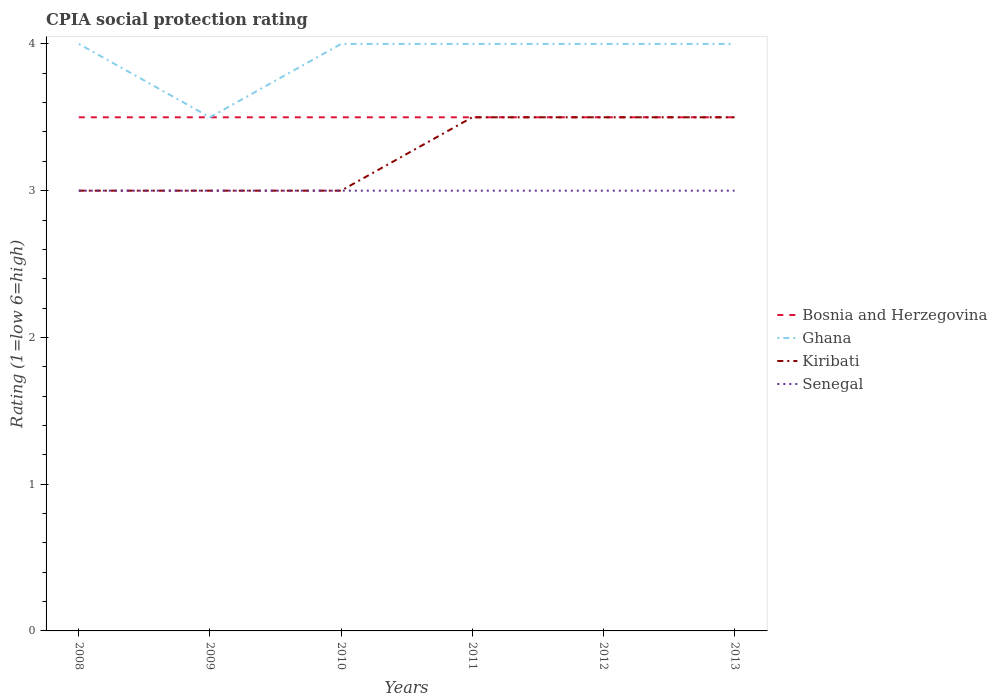Does the line corresponding to Bosnia and Herzegovina intersect with the line corresponding to Kiribati?
Provide a short and direct response. Yes. Across all years, what is the maximum CPIA rating in Senegal?
Provide a succinct answer. 3. In which year was the CPIA rating in Kiribati maximum?
Offer a very short reply. 2008. Is the CPIA rating in Senegal strictly greater than the CPIA rating in Bosnia and Herzegovina over the years?
Provide a succinct answer. Yes. How many years are there in the graph?
Your answer should be very brief. 6. What is the difference between two consecutive major ticks on the Y-axis?
Your answer should be very brief. 1. Does the graph contain grids?
Provide a succinct answer. No. How many legend labels are there?
Provide a short and direct response. 4. What is the title of the graph?
Provide a short and direct response. CPIA social protection rating. What is the label or title of the X-axis?
Provide a short and direct response. Years. What is the label or title of the Y-axis?
Your answer should be compact. Rating (1=low 6=high). What is the Rating (1=low 6=high) of Ghana in 2008?
Offer a very short reply. 4. What is the Rating (1=low 6=high) in Kiribati in 2008?
Your response must be concise. 3. What is the Rating (1=low 6=high) of Senegal in 2008?
Your answer should be compact. 3. What is the Rating (1=low 6=high) of Bosnia and Herzegovina in 2009?
Make the answer very short. 3.5. What is the Rating (1=low 6=high) of Senegal in 2009?
Your response must be concise. 3. What is the Rating (1=low 6=high) of Bosnia and Herzegovina in 2010?
Offer a very short reply. 3.5. What is the Rating (1=low 6=high) in Senegal in 2010?
Provide a succinct answer. 3. What is the Rating (1=low 6=high) in Ghana in 2011?
Give a very brief answer. 4. What is the Rating (1=low 6=high) in Bosnia and Herzegovina in 2012?
Your answer should be very brief. 3.5. What is the Rating (1=low 6=high) in Ghana in 2012?
Make the answer very short. 4. What is the Rating (1=low 6=high) of Kiribati in 2012?
Keep it short and to the point. 3.5. What is the Rating (1=low 6=high) of Bosnia and Herzegovina in 2013?
Your response must be concise. 3.5. What is the Rating (1=low 6=high) in Ghana in 2013?
Keep it short and to the point. 4. Across all years, what is the maximum Rating (1=low 6=high) of Bosnia and Herzegovina?
Your answer should be compact. 3.5. Across all years, what is the maximum Rating (1=low 6=high) in Kiribati?
Ensure brevity in your answer.  3.5. Across all years, what is the maximum Rating (1=low 6=high) of Senegal?
Offer a terse response. 3. Across all years, what is the minimum Rating (1=low 6=high) in Bosnia and Herzegovina?
Give a very brief answer. 3.5. What is the total Rating (1=low 6=high) in Ghana in the graph?
Your answer should be compact. 23.5. What is the difference between the Rating (1=low 6=high) of Ghana in 2008 and that in 2009?
Keep it short and to the point. 0.5. What is the difference between the Rating (1=low 6=high) in Kiribati in 2008 and that in 2009?
Your answer should be compact. 0. What is the difference between the Rating (1=low 6=high) of Senegal in 2008 and that in 2009?
Provide a succinct answer. 0. What is the difference between the Rating (1=low 6=high) of Bosnia and Herzegovina in 2008 and that in 2010?
Make the answer very short. 0. What is the difference between the Rating (1=low 6=high) of Ghana in 2008 and that in 2010?
Your response must be concise. 0. What is the difference between the Rating (1=low 6=high) in Senegal in 2008 and that in 2010?
Offer a terse response. 0. What is the difference between the Rating (1=low 6=high) in Ghana in 2008 and that in 2012?
Offer a terse response. 0. What is the difference between the Rating (1=low 6=high) of Kiribati in 2008 and that in 2012?
Ensure brevity in your answer.  -0.5. What is the difference between the Rating (1=low 6=high) in Senegal in 2008 and that in 2012?
Give a very brief answer. 0. What is the difference between the Rating (1=low 6=high) in Ghana in 2008 and that in 2013?
Provide a short and direct response. 0. What is the difference between the Rating (1=low 6=high) in Kiribati in 2008 and that in 2013?
Your answer should be compact. -0.5. What is the difference between the Rating (1=low 6=high) of Bosnia and Herzegovina in 2009 and that in 2010?
Ensure brevity in your answer.  0. What is the difference between the Rating (1=low 6=high) in Kiribati in 2009 and that in 2010?
Ensure brevity in your answer.  0. What is the difference between the Rating (1=low 6=high) in Senegal in 2009 and that in 2010?
Give a very brief answer. 0. What is the difference between the Rating (1=low 6=high) in Ghana in 2009 and that in 2011?
Make the answer very short. -0.5. What is the difference between the Rating (1=low 6=high) in Senegal in 2009 and that in 2011?
Provide a short and direct response. 0. What is the difference between the Rating (1=low 6=high) of Bosnia and Herzegovina in 2009 and that in 2012?
Make the answer very short. 0. What is the difference between the Rating (1=low 6=high) in Bosnia and Herzegovina in 2010 and that in 2011?
Offer a very short reply. 0. What is the difference between the Rating (1=low 6=high) of Kiribati in 2010 and that in 2011?
Offer a terse response. -0.5. What is the difference between the Rating (1=low 6=high) in Kiribati in 2010 and that in 2012?
Offer a terse response. -0.5. What is the difference between the Rating (1=low 6=high) of Bosnia and Herzegovina in 2010 and that in 2013?
Make the answer very short. 0. What is the difference between the Rating (1=low 6=high) of Ghana in 2010 and that in 2013?
Your response must be concise. 0. What is the difference between the Rating (1=low 6=high) in Ghana in 2011 and that in 2012?
Make the answer very short. 0. What is the difference between the Rating (1=low 6=high) in Senegal in 2011 and that in 2012?
Provide a succinct answer. 0. What is the difference between the Rating (1=low 6=high) of Ghana in 2011 and that in 2013?
Give a very brief answer. 0. What is the difference between the Rating (1=low 6=high) in Kiribati in 2011 and that in 2013?
Your response must be concise. 0. What is the difference between the Rating (1=low 6=high) in Senegal in 2011 and that in 2013?
Offer a terse response. 0. What is the difference between the Rating (1=low 6=high) in Ghana in 2012 and that in 2013?
Your answer should be compact. 0. What is the difference between the Rating (1=low 6=high) in Senegal in 2012 and that in 2013?
Your response must be concise. 0. What is the difference between the Rating (1=low 6=high) of Bosnia and Herzegovina in 2008 and the Rating (1=low 6=high) of Ghana in 2009?
Make the answer very short. 0. What is the difference between the Rating (1=low 6=high) in Ghana in 2008 and the Rating (1=low 6=high) in Kiribati in 2009?
Your answer should be compact. 1. What is the difference between the Rating (1=low 6=high) in Ghana in 2008 and the Rating (1=low 6=high) in Senegal in 2009?
Provide a short and direct response. 1. What is the difference between the Rating (1=low 6=high) of Bosnia and Herzegovina in 2008 and the Rating (1=low 6=high) of Kiribati in 2010?
Ensure brevity in your answer.  0.5. What is the difference between the Rating (1=low 6=high) in Ghana in 2008 and the Rating (1=low 6=high) in Senegal in 2010?
Ensure brevity in your answer.  1. What is the difference between the Rating (1=low 6=high) of Bosnia and Herzegovina in 2008 and the Rating (1=low 6=high) of Kiribati in 2011?
Keep it short and to the point. 0. What is the difference between the Rating (1=low 6=high) in Ghana in 2008 and the Rating (1=low 6=high) in Kiribati in 2011?
Provide a succinct answer. 0.5. What is the difference between the Rating (1=low 6=high) of Bosnia and Herzegovina in 2008 and the Rating (1=low 6=high) of Ghana in 2012?
Give a very brief answer. -0.5. What is the difference between the Rating (1=low 6=high) in Bosnia and Herzegovina in 2008 and the Rating (1=low 6=high) in Senegal in 2012?
Make the answer very short. 0.5. What is the difference between the Rating (1=low 6=high) of Ghana in 2008 and the Rating (1=low 6=high) of Senegal in 2012?
Keep it short and to the point. 1. What is the difference between the Rating (1=low 6=high) in Kiribati in 2008 and the Rating (1=low 6=high) in Senegal in 2012?
Offer a terse response. 0. What is the difference between the Rating (1=low 6=high) in Bosnia and Herzegovina in 2008 and the Rating (1=low 6=high) in Senegal in 2013?
Provide a short and direct response. 0.5. What is the difference between the Rating (1=low 6=high) of Ghana in 2008 and the Rating (1=low 6=high) of Senegal in 2013?
Keep it short and to the point. 1. What is the difference between the Rating (1=low 6=high) of Kiribati in 2008 and the Rating (1=low 6=high) of Senegal in 2013?
Ensure brevity in your answer.  0. What is the difference between the Rating (1=low 6=high) in Bosnia and Herzegovina in 2009 and the Rating (1=low 6=high) in Senegal in 2010?
Provide a succinct answer. 0.5. What is the difference between the Rating (1=low 6=high) in Ghana in 2009 and the Rating (1=low 6=high) in Senegal in 2010?
Your response must be concise. 0.5. What is the difference between the Rating (1=low 6=high) in Bosnia and Herzegovina in 2009 and the Rating (1=low 6=high) in Ghana in 2011?
Your answer should be compact. -0.5. What is the difference between the Rating (1=low 6=high) in Bosnia and Herzegovina in 2009 and the Rating (1=low 6=high) in Senegal in 2011?
Keep it short and to the point. 0.5. What is the difference between the Rating (1=low 6=high) of Ghana in 2009 and the Rating (1=low 6=high) of Kiribati in 2011?
Offer a very short reply. 0. What is the difference between the Rating (1=low 6=high) of Ghana in 2009 and the Rating (1=low 6=high) of Senegal in 2011?
Keep it short and to the point. 0.5. What is the difference between the Rating (1=low 6=high) of Kiribati in 2009 and the Rating (1=low 6=high) of Senegal in 2011?
Provide a succinct answer. 0. What is the difference between the Rating (1=low 6=high) in Bosnia and Herzegovina in 2009 and the Rating (1=low 6=high) in Ghana in 2012?
Ensure brevity in your answer.  -0.5. What is the difference between the Rating (1=low 6=high) of Bosnia and Herzegovina in 2009 and the Rating (1=low 6=high) of Senegal in 2012?
Keep it short and to the point. 0.5. What is the difference between the Rating (1=low 6=high) in Ghana in 2009 and the Rating (1=low 6=high) in Senegal in 2012?
Provide a succinct answer. 0.5. What is the difference between the Rating (1=low 6=high) of Kiribati in 2009 and the Rating (1=low 6=high) of Senegal in 2012?
Your answer should be compact. 0. What is the difference between the Rating (1=low 6=high) of Bosnia and Herzegovina in 2009 and the Rating (1=low 6=high) of Ghana in 2013?
Offer a very short reply. -0.5. What is the difference between the Rating (1=low 6=high) in Bosnia and Herzegovina in 2009 and the Rating (1=low 6=high) in Senegal in 2013?
Offer a very short reply. 0.5. What is the difference between the Rating (1=low 6=high) of Ghana in 2009 and the Rating (1=low 6=high) of Kiribati in 2013?
Your response must be concise. 0. What is the difference between the Rating (1=low 6=high) in Ghana in 2009 and the Rating (1=low 6=high) in Senegal in 2013?
Keep it short and to the point. 0.5. What is the difference between the Rating (1=low 6=high) of Kiribati in 2009 and the Rating (1=low 6=high) of Senegal in 2013?
Make the answer very short. 0. What is the difference between the Rating (1=low 6=high) of Bosnia and Herzegovina in 2010 and the Rating (1=low 6=high) of Ghana in 2011?
Your answer should be very brief. -0.5. What is the difference between the Rating (1=low 6=high) in Ghana in 2010 and the Rating (1=low 6=high) in Kiribati in 2011?
Your answer should be compact. 0.5. What is the difference between the Rating (1=low 6=high) of Ghana in 2010 and the Rating (1=low 6=high) of Senegal in 2011?
Your response must be concise. 1. What is the difference between the Rating (1=low 6=high) of Kiribati in 2010 and the Rating (1=low 6=high) of Senegal in 2011?
Your answer should be very brief. 0. What is the difference between the Rating (1=low 6=high) of Bosnia and Herzegovina in 2010 and the Rating (1=low 6=high) of Kiribati in 2012?
Your answer should be compact. 0. What is the difference between the Rating (1=low 6=high) of Bosnia and Herzegovina in 2010 and the Rating (1=low 6=high) of Senegal in 2012?
Your answer should be very brief. 0.5. What is the difference between the Rating (1=low 6=high) of Ghana in 2010 and the Rating (1=low 6=high) of Kiribati in 2012?
Give a very brief answer. 0.5. What is the difference between the Rating (1=low 6=high) of Ghana in 2010 and the Rating (1=low 6=high) of Senegal in 2012?
Your answer should be compact. 1. What is the difference between the Rating (1=low 6=high) in Kiribati in 2010 and the Rating (1=low 6=high) in Senegal in 2012?
Your response must be concise. 0. What is the difference between the Rating (1=low 6=high) in Bosnia and Herzegovina in 2010 and the Rating (1=low 6=high) in Kiribati in 2013?
Provide a succinct answer. 0. What is the difference between the Rating (1=low 6=high) of Kiribati in 2010 and the Rating (1=low 6=high) of Senegal in 2013?
Your response must be concise. 0. What is the difference between the Rating (1=low 6=high) of Bosnia and Herzegovina in 2011 and the Rating (1=low 6=high) of Ghana in 2012?
Give a very brief answer. -0.5. What is the difference between the Rating (1=low 6=high) of Bosnia and Herzegovina in 2011 and the Rating (1=low 6=high) of Kiribati in 2012?
Give a very brief answer. 0. What is the difference between the Rating (1=low 6=high) of Ghana in 2011 and the Rating (1=low 6=high) of Kiribati in 2012?
Give a very brief answer. 0.5. What is the difference between the Rating (1=low 6=high) in Ghana in 2011 and the Rating (1=low 6=high) in Senegal in 2012?
Keep it short and to the point. 1. What is the difference between the Rating (1=low 6=high) of Bosnia and Herzegovina in 2011 and the Rating (1=low 6=high) of Ghana in 2013?
Your response must be concise. -0.5. What is the difference between the Rating (1=low 6=high) in Bosnia and Herzegovina in 2011 and the Rating (1=low 6=high) in Kiribati in 2013?
Provide a short and direct response. 0. What is the difference between the Rating (1=low 6=high) of Ghana in 2011 and the Rating (1=low 6=high) of Senegal in 2013?
Keep it short and to the point. 1. What is the difference between the Rating (1=low 6=high) of Kiribati in 2011 and the Rating (1=low 6=high) of Senegal in 2013?
Offer a terse response. 0.5. What is the average Rating (1=low 6=high) in Bosnia and Herzegovina per year?
Keep it short and to the point. 3.5. What is the average Rating (1=low 6=high) of Ghana per year?
Provide a succinct answer. 3.92. What is the average Rating (1=low 6=high) in Senegal per year?
Provide a succinct answer. 3. In the year 2008, what is the difference between the Rating (1=low 6=high) in Bosnia and Herzegovina and Rating (1=low 6=high) in Ghana?
Your answer should be very brief. -0.5. In the year 2008, what is the difference between the Rating (1=low 6=high) of Bosnia and Herzegovina and Rating (1=low 6=high) of Kiribati?
Your answer should be compact. 0.5. In the year 2008, what is the difference between the Rating (1=low 6=high) in Ghana and Rating (1=low 6=high) in Kiribati?
Offer a very short reply. 1. In the year 2008, what is the difference between the Rating (1=low 6=high) of Ghana and Rating (1=low 6=high) of Senegal?
Your answer should be compact. 1. In the year 2009, what is the difference between the Rating (1=low 6=high) of Bosnia and Herzegovina and Rating (1=low 6=high) of Ghana?
Make the answer very short. 0. In the year 2009, what is the difference between the Rating (1=low 6=high) in Bosnia and Herzegovina and Rating (1=low 6=high) in Kiribati?
Provide a short and direct response. 0.5. In the year 2009, what is the difference between the Rating (1=low 6=high) in Bosnia and Herzegovina and Rating (1=low 6=high) in Senegal?
Your response must be concise. 0.5. In the year 2009, what is the difference between the Rating (1=low 6=high) of Ghana and Rating (1=low 6=high) of Kiribati?
Give a very brief answer. 0.5. In the year 2009, what is the difference between the Rating (1=low 6=high) in Ghana and Rating (1=low 6=high) in Senegal?
Ensure brevity in your answer.  0.5. In the year 2010, what is the difference between the Rating (1=low 6=high) in Bosnia and Herzegovina and Rating (1=low 6=high) in Ghana?
Provide a succinct answer. -0.5. In the year 2010, what is the difference between the Rating (1=low 6=high) in Bosnia and Herzegovina and Rating (1=low 6=high) in Kiribati?
Your response must be concise. 0.5. In the year 2011, what is the difference between the Rating (1=low 6=high) of Ghana and Rating (1=low 6=high) of Kiribati?
Offer a very short reply. 0.5. In the year 2011, what is the difference between the Rating (1=low 6=high) of Ghana and Rating (1=low 6=high) of Senegal?
Offer a terse response. 1. In the year 2012, what is the difference between the Rating (1=low 6=high) in Bosnia and Herzegovina and Rating (1=low 6=high) in Ghana?
Keep it short and to the point. -0.5. In the year 2012, what is the difference between the Rating (1=low 6=high) in Ghana and Rating (1=low 6=high) in Kiribati?
Your answer should be compact. 0.5. In the year 2012, what is the difference between the Rating (1=low 6=high) of Kiribati and Rating (1=low 6=high) of Senegal?
Your answer should be very brief. 0.5. In the year 2013, what is the difference between the Rating (1=low 6=high) in Bosnia and Herzegovina and Rating (1=low 6=high) in Kiribati?
Make the answer very short. 0. In the year 2013, what is the difference between the Rating (1=low 6=high) of Ghana and Rating (1=low 6=high) of Senegal?
Offer a very short reply. 1. What is the ratio of the Rating (1=low 6=high) of Ghana in 2008 to that in 2009?
Your answer should be very brief. 1.14. What is the ratio of the Rating (1=low 6=high) in Ghana in 2008 to that in 2010?
Provide a short and direct response. 1. What is the ratio of the Rating (1=low 6=high) of Bosnia and Herzegovina in 2008 to that in 2011?
Provide a succinct answer. 1. What is the ratio of the Rating (1=low 6=high) of Kiribati in 2008 to that in 2011?
Offer a terse response. 0.86. What is the ratio of the Rating (1=low 6=high) in Senegal in 2008 to that in 2011?
Make the answer very short. 1. What is the ratio of the Rating (1=low 6=high) of Ghana in 2008 to that in 2012?
Keep it short and to the point. 1. What is the ratio of the Rating (1=low 6=high) in Kiribati in 2008 to that in 2012?
Your response must be concise. 0.86. What is the ratio of the Rating (1=low 6=high) in Senegal in 2008 to that in 2012?
Provide a short and direct response. 1. What is the ratio of the Rating (1=low 6=high) in Bosnia and Herzegovina in 2008 to that in 2013?
Ensure brevity in your answer.  1. What is the ratio of the Rating (1=low 6=high) in Ghana in 2008 to that in 2013?
Offer a terse response. 1. What is the ratio of the Rating (1=low 6=high) of Kiribati in 2008 to that in 2013?
Your response must be concise. 0.86. What is the ratio of the Rating (1=low 6=high) of Senegal in 2008 to that in 2013?
Provide a succinct answer. 1. What is the ratio of the Rating (1=low 6=high) of Kiribati in 2009 to that in 2010?
Your response must be concise. 1. What is the ratio of the Rating (1=low 6=high) of Senegal in 2009 to that in 2010?
Give a very brief answer. 1. What is the ratio of the Rating (1=low 6=high) in Bosnia and Herzegovina in 2009 to that in 2011?
Provide a succinct answer. 1. What is the ratio of the Rating (1=low 6=high) of Ghana in 2009 to that in 2011?
Offer a very short reply. 0.88. What is the ratio of the Rating (1=low 6=high) of Kiribati in 2009 to that in 2011?
Ensure brevity in your answer.  0.86. What is the ratio of the Rating (1=low 6=high) in Senegal in 2009 to that in 2011?
Your response must be concise. 1. What is the ratio of the Rating (1=low 6=high) of Bosnia and Herzegovina in 2009 to that in 2012?
Provide a succinct answer. 1. What is the ratio of the Rating (1=low 6=high) of Ghana in 2009 to that in 2012?
Provide a short and direct response. 0.88. What is the ratio of the Rating (1=low 6=high) in Senegal in 2009 to that in 2012?
Your answer should be compact. 1. What is the ratio of the Rating (1=low 6=high) in Bosnia and Herzegovina in 2009 to that in 2013?
Your answer should be compact. 1. What is the ratio of the Rating (1=low 6=high) of Kiribati in 2009 to that in 2013?
Your answer should be very brief. 0.86. What is the ratio of the Rating (1=low 6=high) of Senegal in 2009 to that in 2013?
Give a very brief answer. 1. What is the ratio of the Rating (1=low 6=high) of Ghana in 2010 to that in 2011?
Provide a short and direct response. 1. What is the ratio of the Rating (1=low 6=high) of Kiribati in 2010 to that in 2011?
Offer a very short reply. 0.86. What is the ratio of the Rating (1=low 6=high) of Senegal in 2010 to that in 2011?
Your answer should be very brief. 1. What is the ratio of the Rating (1=low 6=high) of Bosnia and Herzegovina in 2010 to that in 2012?
Provide a short and direct response. 1. What is the ratio of the Rating (1=low 6=high) of Ghana in 2010 to that in 2012?
Ensure brevity in your answer.  1. What is the ratio of the Rating (1=low 6=high) in Kiribati in 2010 to that in 2012?
Your answer should be very brief. 0.86. What is the ratio of the Rating (1=low 6=high) in Kiribati in 2010 to that in 2013?
Provide a succinct answer. 0.86. What is the ratio of the Rating (1=low 6=high) of Bosnia and Herzegovina in 2011 to that in 2012?
Keep it short and to the point. 1. What is the ratio of the Rating (1=low 6=high) of Ghana in 2011 to that in 2012?
Offer a very short reply. 1. What is the ratio of the Rating (1=low 6=high) in Ghana in 2011 to that in 2013?
Keep it short and to the point. 1. What is the ratio of the Rating (1=low 6=high) in Senegal in 2011 to that in 2013?
Your answer should be very brief. 1. What is the ratio of the Rating (1=low 6=high) in Bosnia and Herzegovina in 2012 to that in 2013?
Your answer should be compact. 1. What is the difference between the highest and the second highest Rating (1=low 6=high) of Ghana?
Offer a very short reply. 0. What is the difference between the highest and the second highest Rating (1=low 6=high) in Kiribati?
Make the answer very short. 0. What is the difference between the highest and the second highest Rating (1=low 6=high) of Senegal?
Your response must be concise. 0. What is the difference between the highest and the lowest Rating (1=low 6=high) in Kiribati?
Provide a short and direct response. 0.5. 